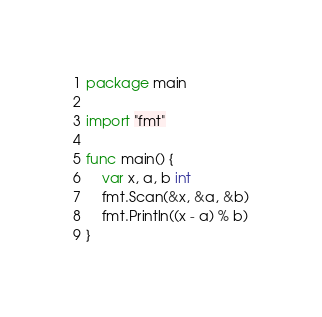<code> <loc_0><loc_0><loc_500><loc_500><_Go_>package main

import "fmt"

func main() {
	var x, a, b int
	fmt.Scan(&x, &a, &b)
	fmt.Println((x - a) % b)
}
</code> 